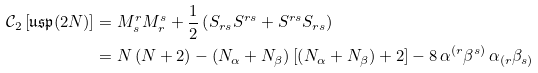Convert formula to latex. <formula><loc_0><loc_0><loc_500><loc_500>\mathcal { C } _ { 2 } \left [ \mathfrak { u s p } ( 2 N ) \right ] & = M ^ { r } _ { s } M ^ { s } _ { r } + \frac { 1 } { 2 } \left ( S _ { r s } S ^ { r s } + S ^ { r s } S _ { r s } \right ) \\ & = N \left ( N + 2 \right ) - \left ( N _ { \alpha } + N _ { \beta } \right ) \left [ \left ( N _ { \alpha } + N _ { \beta } \right ) + 2 \right ] - 8 \, \alpha ^ { ( r } \beta ^ { s ) } \, \alpha _ { ( r } \beta _ { s ) }</formula> 